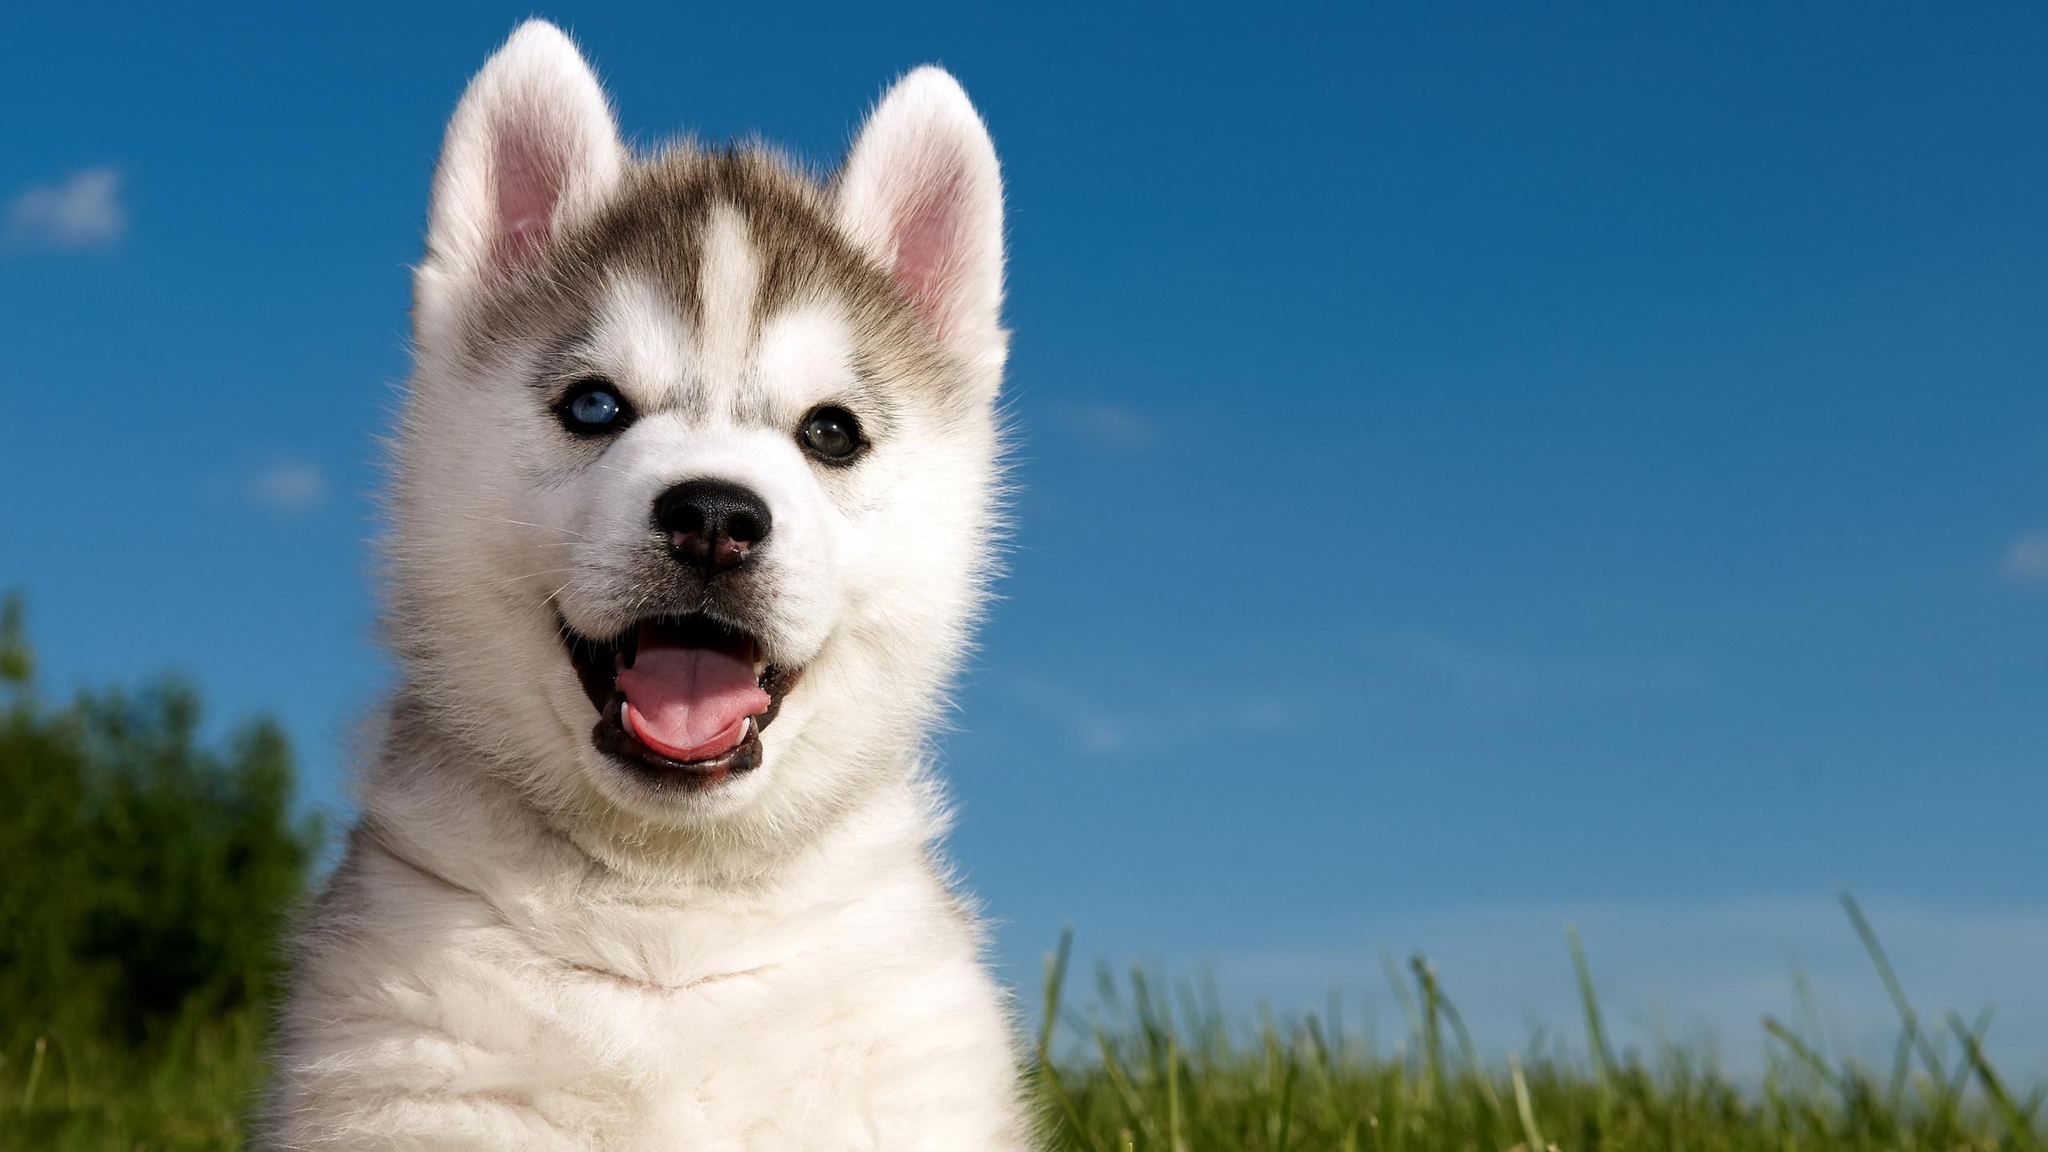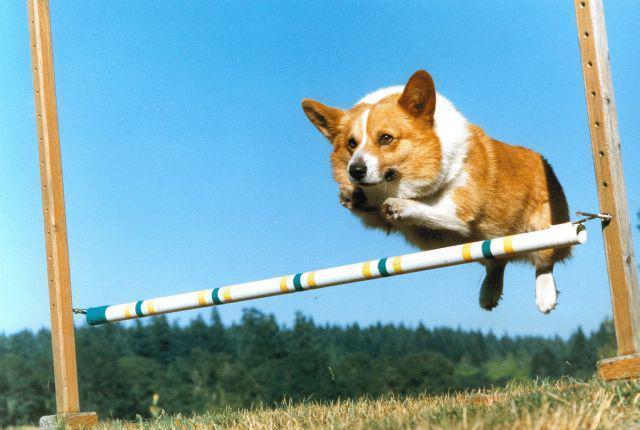The first image is the image on the left, the second image is the image on the right. Given the left and right images, does the statement "In at least one image there is  a corgi white a black belly jumping in the are with it tongue wagging" hold true? Answer yes or no. No. The first image is the image on the left, the second image is the image on the right. Analyze the images presented: Is the assertion "One dog is in snow." valid? Answer yes or no. No. 